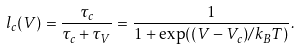Convert formula to latex. <formula><loc_0><loc_0><loc_500><loc_500>l _ { c } ( V ) = \frac { \tau _ { c } } { \tau _ { c } + \tau _ { V } } = \frac { 1 } { 1 + \exp ( ( V - V _ { c } ) / k _ { B } T ) } .</formula> 